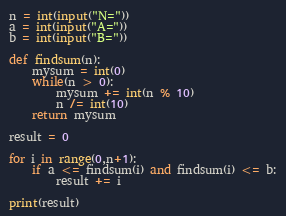<code> <loc_0><loc_0><loc_500><loc_500><_Python_>n = int(input("N="))
a = int(input("A="))
b = int(input("B="))

def findsum(n):
    mysum = int(0)
    while(n > 0):
        mysum += int(n % 10)
        n /= int(10)
    return mysum

result = 0

for i in range(0,n+1):
    if a <= findsum(i) and findsum(i) <= b:
        result += i

print(result)</code> 